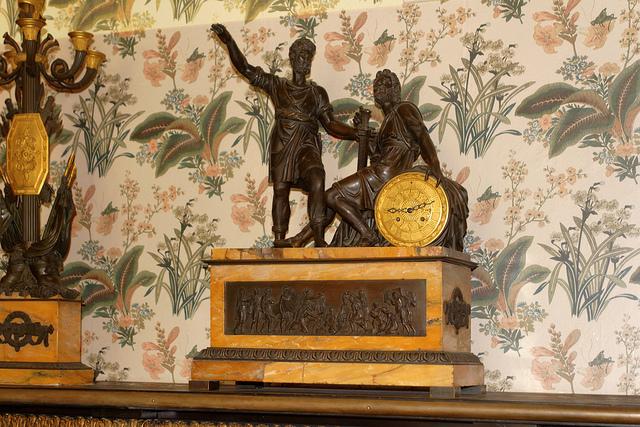Is this a clock?
Quick response, please. Yes. Does the wall have a flower pattern?
Be succinct. Yes. How many statues are sitting on the clock?
Write a very short answer. 2. 